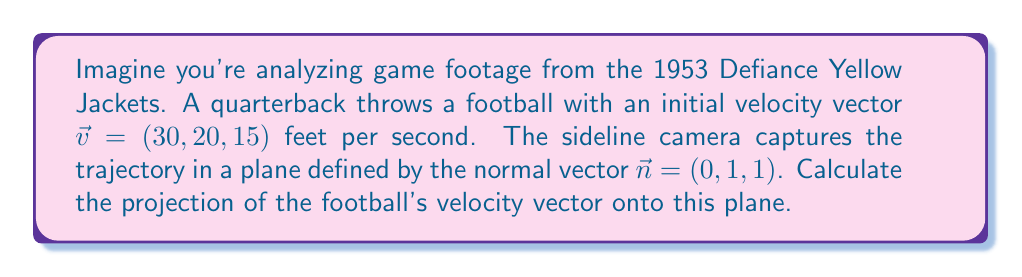Can you solve this math problem? To solve this problem, we'll use the formula for vector projection onto a plane:

$$\vec{v}_{\text{proj}} = \vec{v} - \frac{\vec{v} \cdot \vec{n}}{\|\vec{n}\|^2} \vec{n}$$

Step 1: Calculate the dot product of $\vec{v}$ and $\vec{n}$:
$$\vec{v} \cdot \vec{n} = 30(0) + 20(1) + 15(1) = 35$$

Step 2: Calculate the magnitude of $\vec{n}$ squared:
$$\|\vec{n}\|^2 = 0^2 + 1^2 + 1^2 = 2$$

Step 3: Calculate the scalar projection:
$$\frac{\vec{v} \cdot \vec{n}}{\|\vec{n}\|^2} = \frac{35}{2} = 17.5$$

Step 4: Multiply this scalar by $\vec{n}$:
$$17.5 \vec{n} = (0, 17.5, 17.5)$$

Step 5: Subtract this vector from $\vec{v}$:
$$\vec{v}_{\text{proj}} = (30, 20, 15) - (0, 17.5, 17.5) = (30, 2.5, -2.5)$$

Therefore, the projection of the football's velocity vector onto the plane is $(30, 2.5, -2.5)$ feet per second.
Answer: $(30, 2.5, -2.5)$ ft/s 